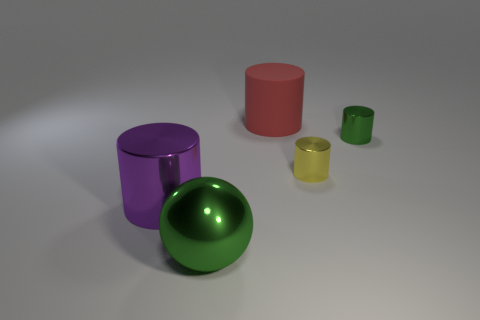Subtract all metallic cylinders. How many cylinders are left? 1 Subtract 2 cylinders. How many cylinders are left? 2 Subtract all red cylinders. How many cylinders are left? 3 Add 1 big purple balls. How many objects exist? 6 Subtract all purple cylinders. Subtract all green spheres. How many cylinders are left? 3 Subtract all balls. How many objects are left? 4 Subtract all tiny brown cylinders. Subtract all large objects. How many objects are left? 2 Add 4 yellow things. How many yellow things are left? 5 Add 2 cylinders. How many cylinders exist? 6 Subtract 0 gray cylinders. How many objects are left? 5 